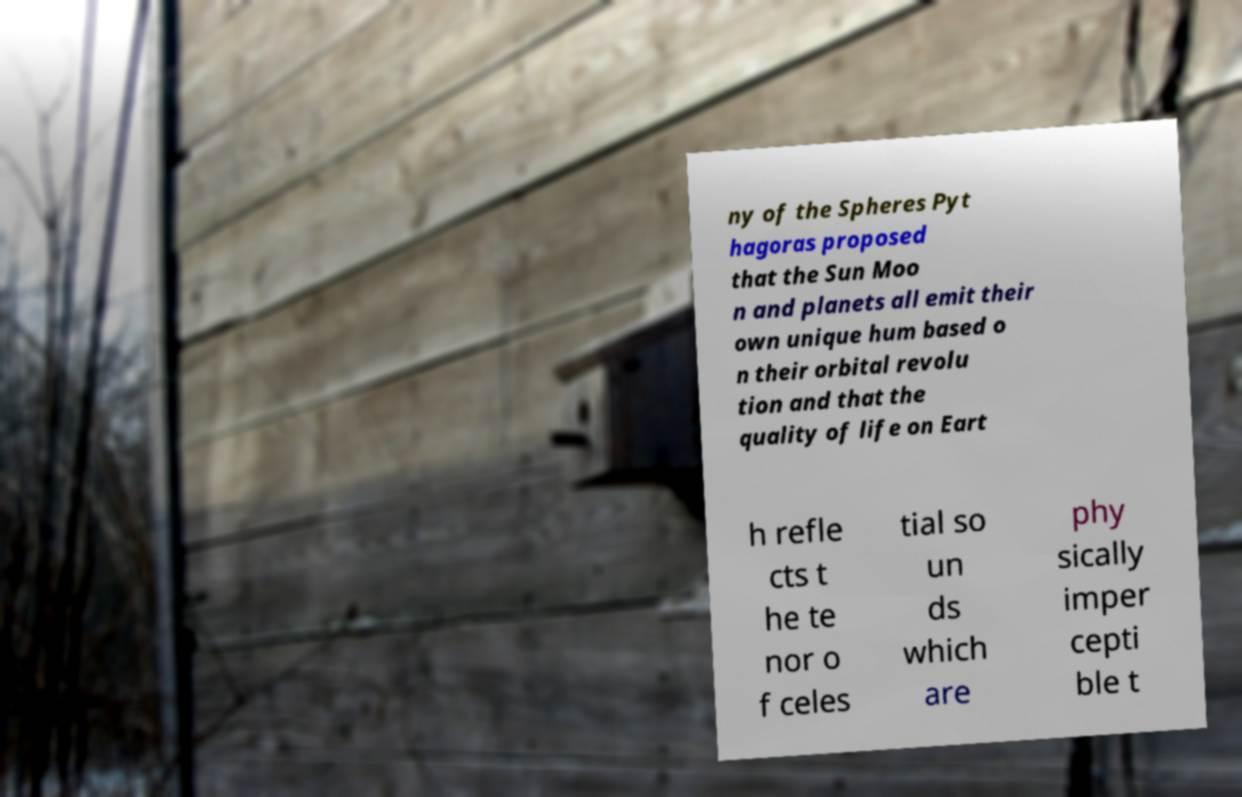Please read and relay the text visible in this image. What does it say? ny of the Spheres Pyt hagoras proposed that the Sun Moo n and planets all emit their own unique hum based o n their orbital revolu tion and that the quality of life on Eart h refle cts t he te nor o f celes tial so un ds which are phy sically imper cepti ble t 